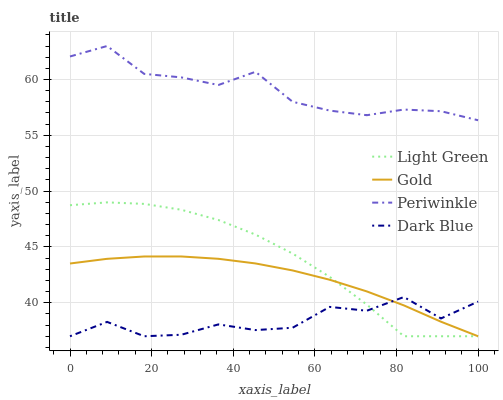Does Dark Blue have the minimum area under the curve?
Answer yes or no. Yes. Does Gold have the minimum area under the curve?
Answer yes or no. No. Does Gold have the maximum area under the curve?
Answer yes or no. No. Is Gold the smoothest?
Answer yes or no. Yes. Is Dark Blue the roughest?
Answer yes or no. Yes. Is Periwinkle the smoothest?
Answer yes or no. No. Is Periwinkle the roughest?
Answer yes or no. No. Does Periwinkle have the lowest value?
Answer yes or no. No. Does Gold have the highest value?
Answer yes or no. No. Is Dark Blue less than Periwinkle?
Answer yes or no. Yes. Is Periwinkle greater than Dark Blue?
Answer yes or no. Yes. Does Dark Blue intersect Periwinkle?
Answer yes or no. No. 